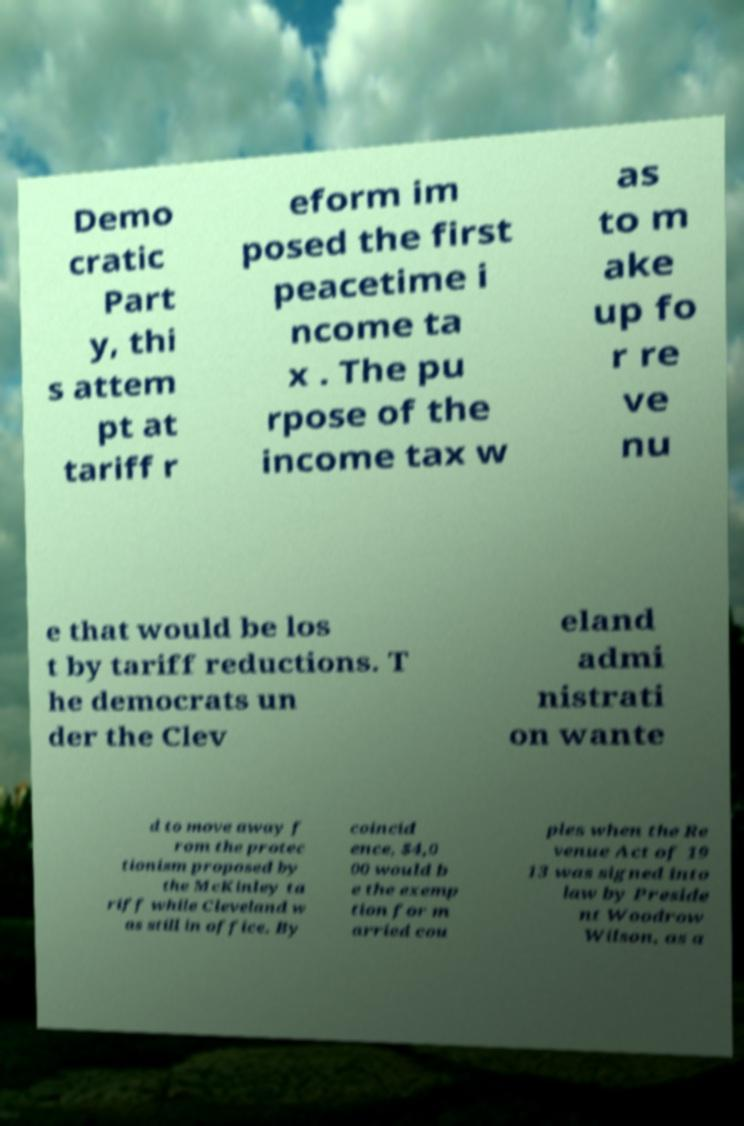Could you extract and type out the text from this image? Demo cratic Part y, thi s attem pt at tariff r eform im posed the first peacetime i ncome ta x . The pu rpose of the income tax w as to m ake up fo r re ve nu e that would be los t by tariff reductions. T he democrats un der the Clev eland admi nistrati on wante d to move away f rom the protec tionism proposed by the McKinley ta riff while Cleveland w as still in office. By coincid ence, $4,0 00 would b e the exemp tion for m arried cou ples when the Re venue Act of 19 13 was signed into law by Preside nt Woodrow Wilson, as a 